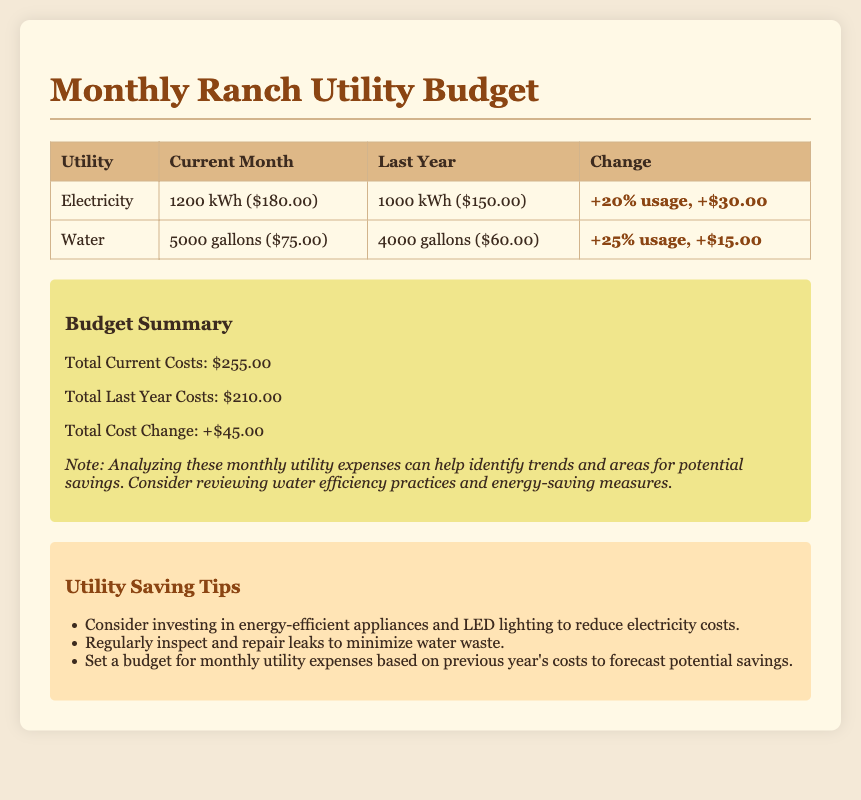What is the electricity cost for the current month? The current month electricity cost is listed as $180.00.
Answer: $180.00 What was the water usage last year? Last year's water usage is recorded as 4000 gallons.
Answer: 4000 gallons What is the total cost change from last year to this year? The total cost change is stated as +$45.00.
Answer: +$45.00 What percentage increase in electricity usage is noted? The document shows a +20% increase in electricity usage.
Answer: +20% What tips are provided for saving utilities? Tips include investing in energy-efficient appliances and inspecting leaks among others.
Answer: Energy-efficient appliances; inspect leaks What was the total current costs for utilities? The total current costs are summed as $255.00.
Answer: $255.00 What is the change in water costs compared to last year? The change in water costs is +$15.00, reflecting increased usage.
Answer: +$15.00 How many gallons of water were used in the current month? The current month shows a usage of 5000 gallons of water.
Answer: 5000 gallons What is the electricity usage for the current month? Current month's electricity usage is 1200 kWh.
Answer: 1200 kWh 